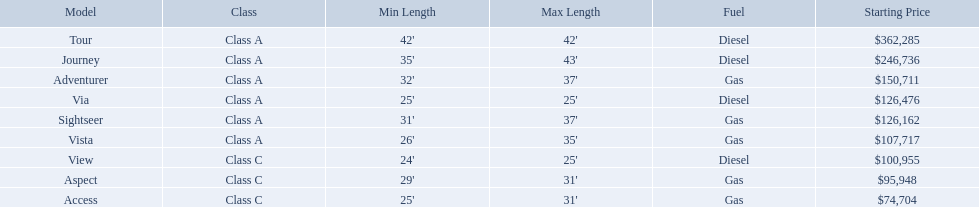Would you be able to parse every entry in this table? {'header': ['Model', 'Class', 'Min Length', 'Max Length', 'Fuel', 'Starting Price'], 'rows': [['Tour', 'Class A', "42'", "42'", 'Diesel', '$362,285'], ['Journey', 'Class A', "35'", "43'", 'Diesel', '$246,736'], ['Adventurer', 'Class A', "32'", "37'", 'Gas', '$150,711'], ['Via', 'Class A', "25'", "25'", 'Diesel', '$126,476'], ['Sightseer', 'Class A', "31'", "37'", 'Gas', '$126,162'], ['Vista', 'Class A', "26'", "35'", 'Gas', '$107,717'], ['View', 'Class C', "24'", "25'", 'Diesel', '$100,955'], ['Aspect', 'Class C', "29'", "31'", 'Gas', '$95,948'], ['Access', 'Class C', "25'", "31'", 'Gas', '$74,704']]} Which models are manufactured by winnebago industries? Tour, Journey, Adventurer, Via, Sightseer, Vista, View, Aspect, Access. What type of fuel does each model require? Diesel, Diesel, Gas, Diesel, Gas, Gas, Diesel, Gas, Gas. And between the tour and aspect, which runs on diesel? Tour. What are all the class a models of the winnebago industries? Tour, Journey, Adventurer, Via, Sightseer, Vista. Of those class a models, which has the highest starting price? Tour. Which model has the lowest starting price? Access. Which model has the second most highest starting price? Journey. Which model has the highest price in the winnebago industry? Tour. What models are available from winnebago industries? Tour, Journey, Adventurer, Via, Sightseer, Vista, View, Aspect, Access. What are their starting prices? $362,285, $246,736, $150,711, $126,476, $126,162, $107,717, $100,955, $95,948, $74,704. Which model has the most costly starting price? Tour. What are all of the winnebago models? Tour, Journey, Adventurer, Via, Sightseer, Vista, View, Aspect, Access. What are their prices? $362,285, $246,736, $150,711, $126,476, $126,162, $107,717, $100,955, $95,948, $74,704. And which model costs the most? Tour. What is the highest price of a winnebago model? $362,285. What is the name of the vehicle with this price? Tour. 